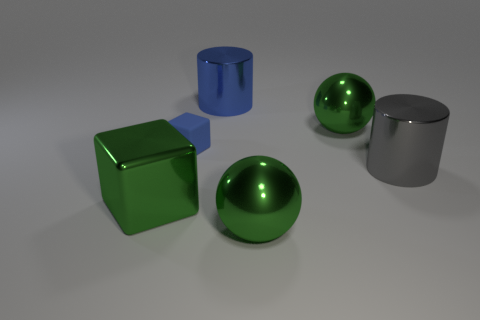What is the color of the metallic cube that is the same size as the blue metallic thing?
Make the answer very short. Green. Is there a small matte cylinder of the same color as the tiny object?
Offer a terse response. No. The gray thing that is the same material as the large green cube is what size?
Give a very brief answer. Large. There is a object that is the same color as the matte cube; what size is it?
Your answer should be compact. Large. What number of other objects are the same size as the gray thing?
Your answer should be very brief. 4. There is a cylinder in front of the blue metallic cylinder; what material is it?
Ensure brevity in your answer.  Metal. The big thing that is on the right side of the green ball that is behind the green thing in front of the large cube is what shape?
Your answer should be very brief. Cylinder. Is the size of the gray cylinder the same as the green shiny block?
Your answer should be compact. Yes. What number of objects are either shiny spheres or tiny rubber things that are left of the big blue thing?
Offer a terse response. 3. How many objects are either metallic objects in front of the gray metallic cylinder or green things that are right of the small thing?
Give a very brief answer. 3. 